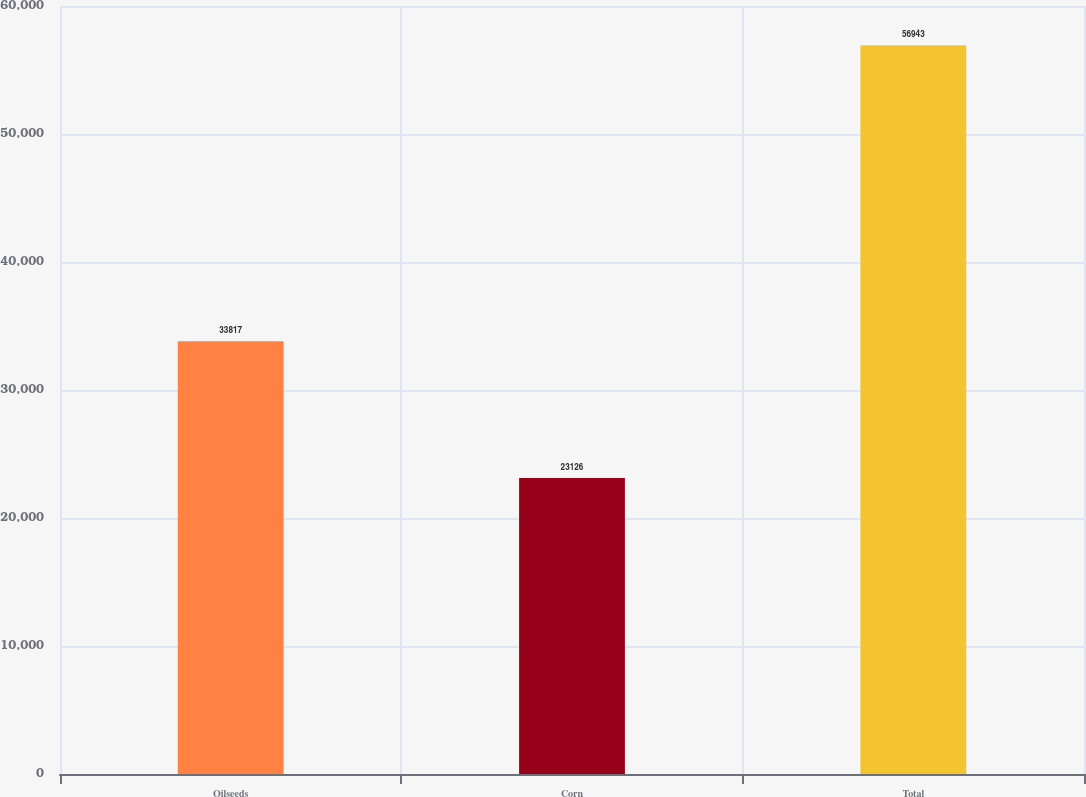<chart> <loc_0><loc_0><loc_500><loc_500><bar_chart><fcel>Oilseeds<fcel>Corn<fcel>Total<nl><fcel>33817<fcel>23126<fcel>56943<nl></chart> 